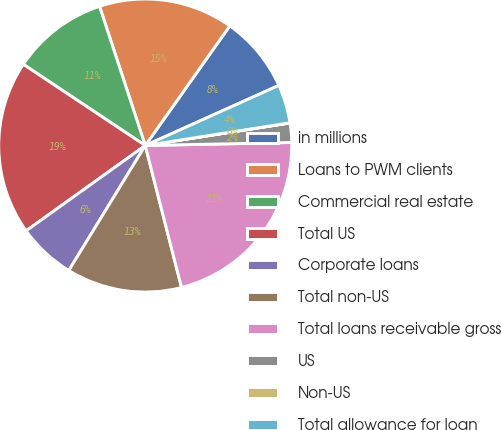Convert chart. <chart><loc_0><loc_0><loc_500><loc_500><pie_chart><fcel>in millions<fcel>Loans to PWM clients<fcel>Commercial real estate<fcel>Total US<fcel>Corporate loans<fcel>Total non-US<fcel>Total loans receivable gross<fcel>US<fcel>Non-US<fcel>Total allowance for loan<nl><fcel>8.48%<fcel>14.84%<fcel>10.6%<fcel>19.24%<fcel>6.37%<fcel>12.72%<fcel>21.35%<fcel>2.13%<fcel>0.02%<fcel>4.25%<nl></chart> 